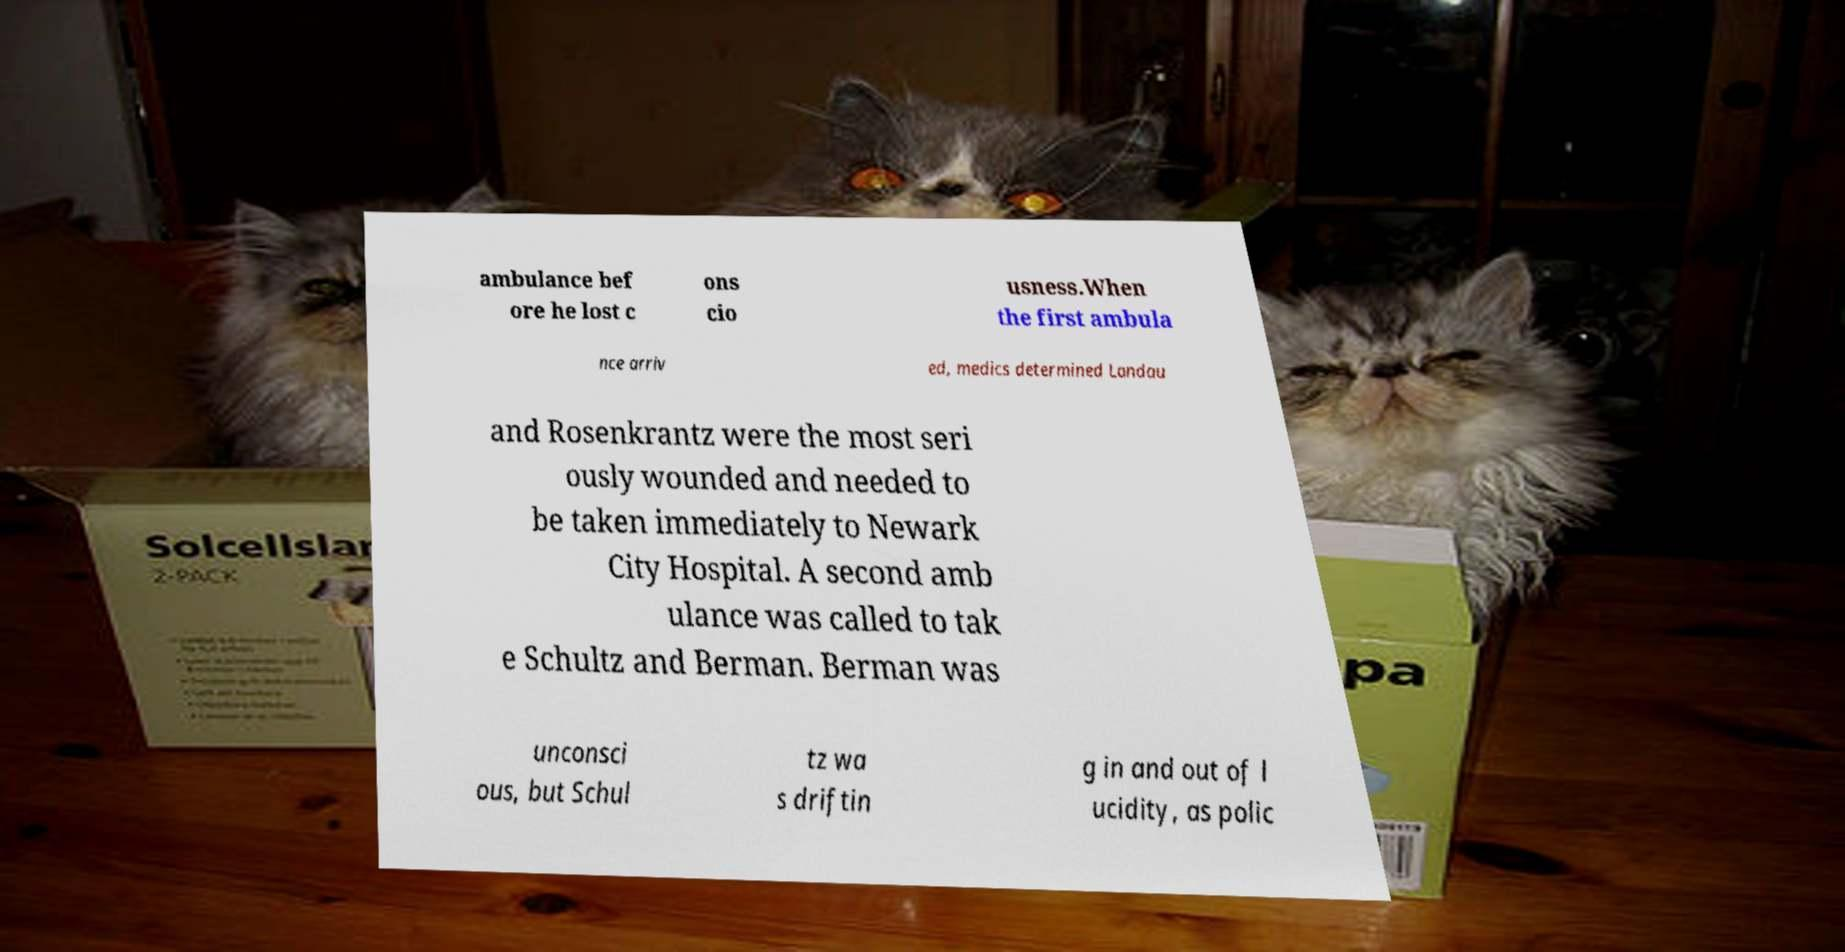What messages or text are displayed in this image? I need them in a readable, typed format. ambulance bef ore he lost c ons cio usness.When the first ambula nce arriv ed, medics determined Landau and Rosenkrantz were the most seri ously wounded and needed to be taken immediately to Newark City Hospital. A second amb ulance was called to tak e Schultz and Berman. Berman was unconsci ous, but Schul tz wa s driftin g in and out of l ucidity, as polic 